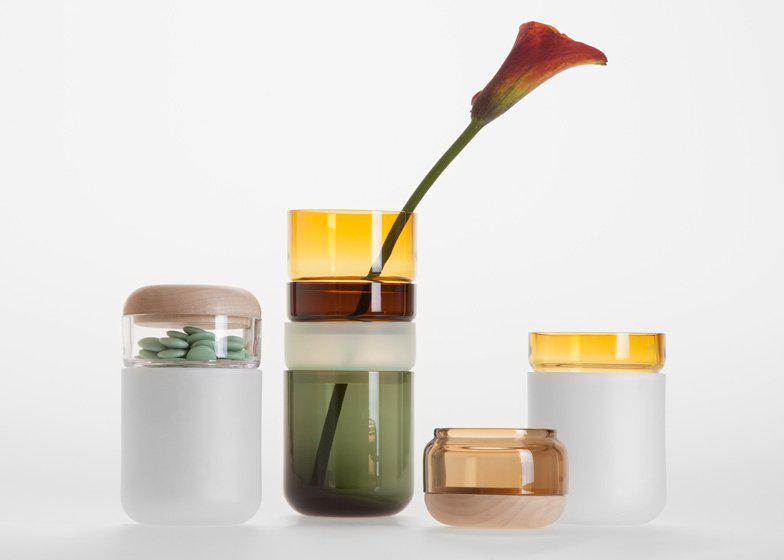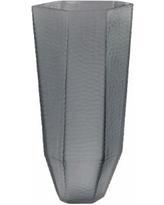The first image is the image on the left, the second image is the image on the right. Examine the images to the left and right. Is the description "all vases have muted colors and some with flowers" accurate? Answer yes or no. No. The first image is the image on the left, the second image is the image on the right. Analyze the images presented: Is the assertion "All photos have exactly three vases or jars positioned in close proximity to each other." valid? Answer yes or no. No. 